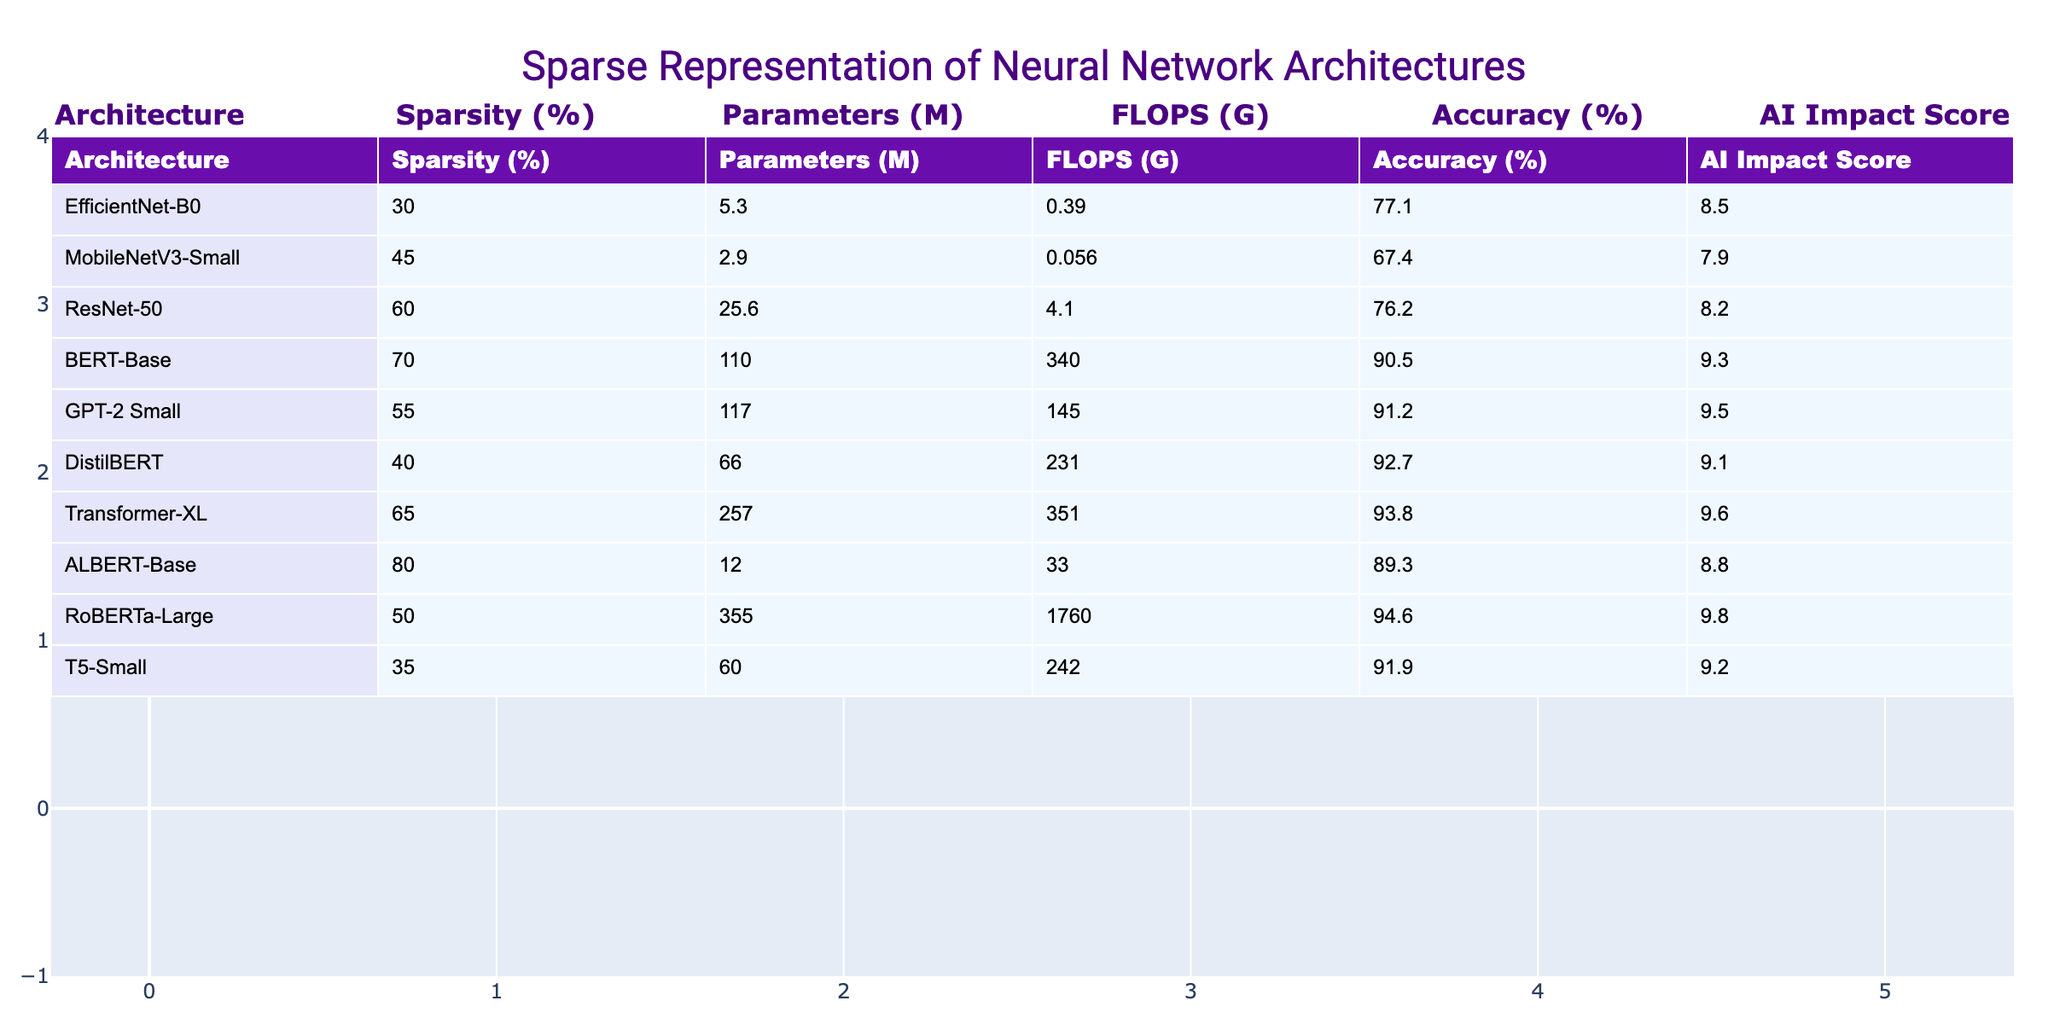What is the sparsity percentage of the BERT-Base architecture? The table lists the BERT-Base architecture with a corresponding sparsity percentage of 70%.
Answer: 70% Which architecture has the highest accuracy? By reviewing the accuracies in the table, the RoBERTa-Large architecture has the highest accuracy at 94.6%.
Answer: RoBERTa-Large What is the average number of parameters for architectures with more than 50% sparsity? The architectures with more than 50% sparsity are BERT-Base (110M), GPT-2 Small (117M), DistilBERT (66M), Transformer-XL (257M), and ALBERT-Base (12M). Summing these gives 110 + 117 + 66 + 257 + 12 = 562M. Dividing by 5 gives an average of 562/5 = 112.4M.
Answer: 112.4M Is the MobileNetV3-Small architecture more accurate than EfficientNet-B0? MobileNetV3-Small has an accuracy of 67.4%, while EfficientNet-B0 has an accuracy of 77.1%. Thus, EfficientNet-B0 is more accurate than MobileNetV3-Small.
Answer: No What is the difference in FLOPS between the architecture with the highest sparsity and the one with the lowest? The architecture with the highest sparsity is ALBERT-Base with 80% and has 33 FLOPS (G). The one with the lowest sparsity is MobileNetV3-Small with 45% and has 0.056 FLOPS (G). The difference is 33 - 0.056 = 32.944.
Answer: 32.944 How do the AI Impact Scores correlate with accuracy among the top three architectures? The top three architectures by accuracy are RoBERTa-Large (94.6%), GPT-2 Small (91.2%), and DistilBERT (92.7%) with AI Impact Scores of 9.8, 9.5, and 9.1 respectively. Higher accuracy aligns with higher AI Impact Scores, indicating a positive correlation exists.
Answer: Yes Which architecture has the least number of parameters and what is its AI Impact Score? The architecture with the least number of parameters is MobileNetV3-Small with 2.9M parameters, and its AI Impact Score is 7.9.
Answer: 7.9 Is there a correlation between sparsity percentage and the number of parameters in the table? A correlation can be assessed by examining the sparsity and corresponding parameters. For example, the architecture with the highest sparsity (ALBERT-Base, 80%) has 12M parameters, while one with 30% sparsity (EfficientNet-B0) has 5.3M parameters. This suggests that higher sparsity tends to correspond with fewer parameters, indicating a negative correlation.
Answer: Yes What is the sum of the FLOPS for architectures with greater than 60% sparsity? The architectures with greater than 60% sparsity are BERT-Base (340), GPT-2 Small (145), ResNet-50 (4.1), Transformer-XL (351), ALBERT-Base (33). The sum is 340 + 145 + 4.1 + 351 + 33 = 873.1 FLOPS (G).
Answer: 873.1 Which architecture with less than 50% sparsity has the highest number of parameters? The architectures with less than 50% sparsity are EfficientNet-B0 (5.3M), MobileNetV3-Small (2.9M), T5-Small (60M), and RoBERTa-Large (355M). Among them, RoBERTa-Large has the highest parameters at 355M.
Answer: RoBERTa-Large 